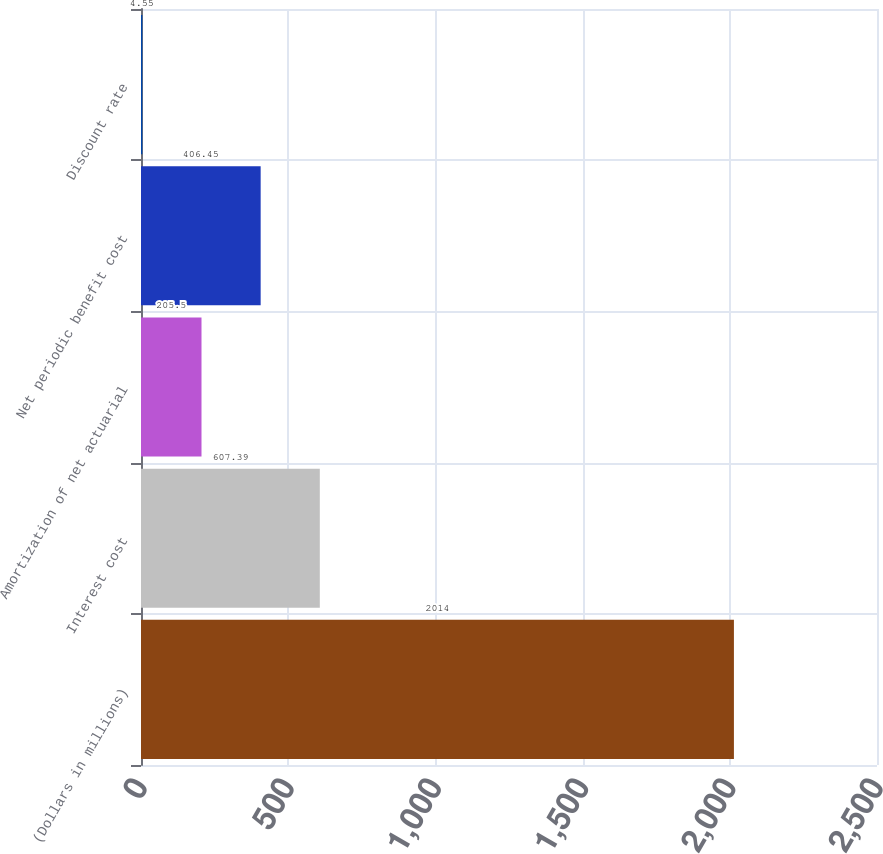Convert chart to OTSL. <chart><loc_0><loc_0><loc_500><loc_500><bar_chart><fcel>(Dollars in millions)<fcel>Interest cost<fcel>Amortization of net actuarial<fcel>Net periodic benefit cost<fcel>Discount rate<nl><fcel>2014<fcel>607.39<fcel>205.5<fcel>406.45<fcel>4.55<nl></chart> 